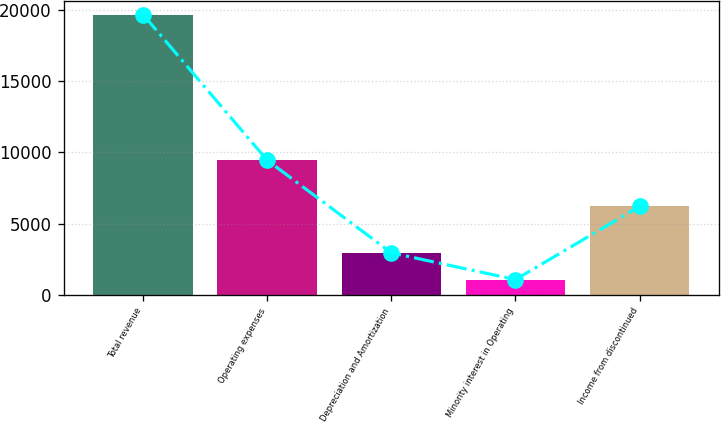Convert chart to OTSL. <chart><loc_0><loc_0><loc_500><loc_500><bar_chart><fcel>Total revenue<fcel>Operating expenses<fcel>Depreciation and Amortization<fcel>Minority interest in Operating<fcel>Income from discontinued<nl><fcel>19665<fcel>9443<fcel>2948<fcel>1068<fcel>6206<nl></chart> 